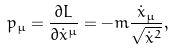Convert formula to latex. <formula><loc_0><loc_0><loc_500><loc_500>p _ { \mu } = \frac { \partial L } { \partial \dot { x } ^ { \mu } } = - m \frac { \dot { x } _ { \mu } } { \sqrt { \dot { x } ^ { 2 } } } ,</formula> 